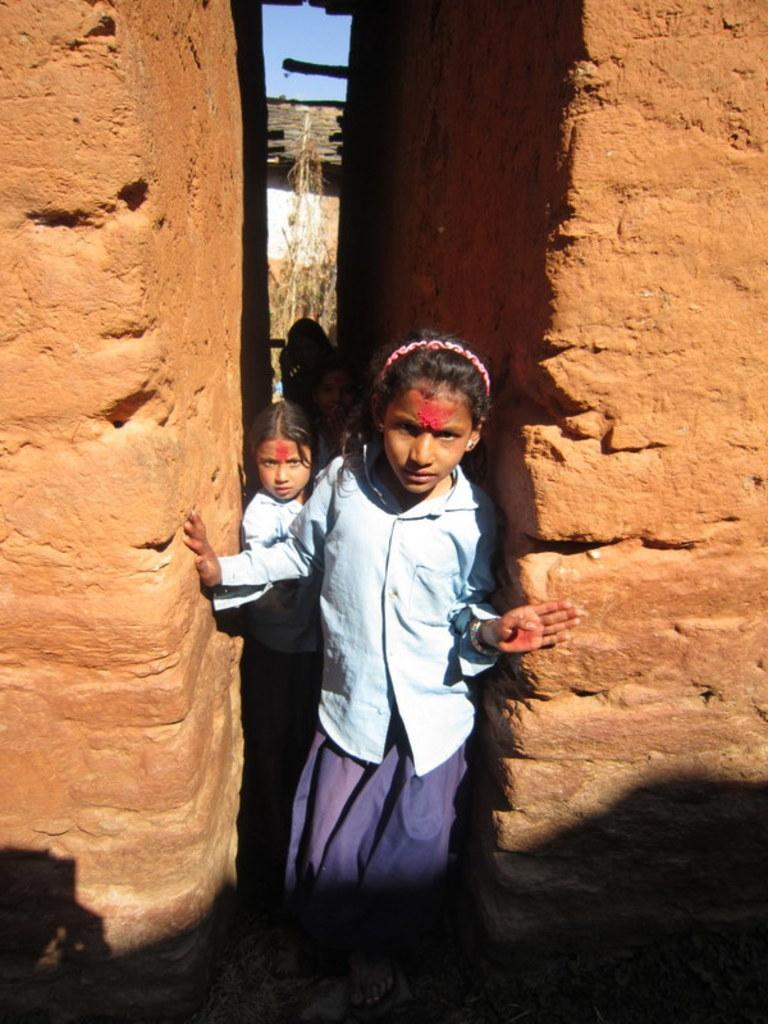How many people are in the image? There are two girls in the image. Where are the girls standing in relation to the buildings? The girls are standing between two buildings. What material are the buildings made of? The buildings are made of red bricks. What type of weather can be seen in the image? The provided facts do not mention any weather conditions, so it cannot be determined from the image. 